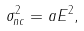<formula> <loc_0><loc_0><loc_500><loc_500>\sigma _ { n c } ^ { 2 } = a E ^ { 2 } ,</formula> 